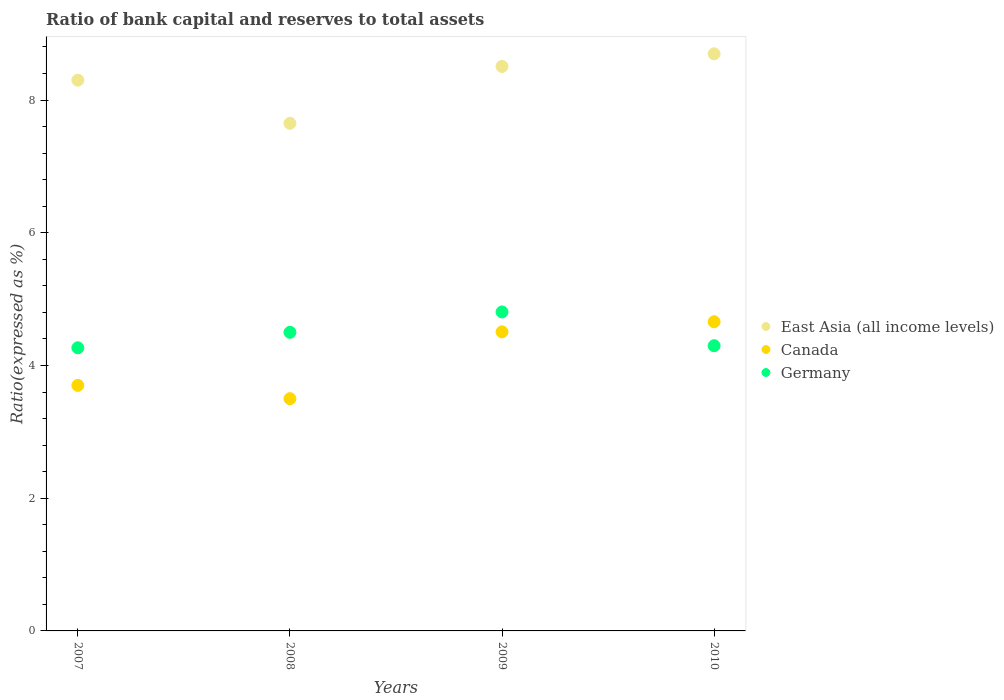How many different coloured dotlines are there?
Give a very brief answer. 3. Is the number of dotlines equal to the number of legend labels?
Provide a succinct answer. Yes. What is the ratio of bank capital and reserves to total assets in East Asia (all income levels) in 2009?
Provide a short and direct response. 8.51. Across all years, what is the maximum ratio of bank capital and reserves to total assets in Canada?
Offer a very short reply. 4.66. Across all years, what is the minimum ratio of bank capital and reserves to total assets in East Asia (all income levels)?
Your response must be concise. 7.65. In which year was the ratio of bank capital and reserves to total assets in East Asia (all income levels) maximum?
Keep it short and to the point. 2010. What is the total ratio of bank capital and reserves to total assets in Germany in the graph?
Provide a short and direct response. 17.87. What is the difference between the ratio of bank capital and reserves to total assets in Germany in 2007 and that in 2008?
Provide a succinct answer. -0.23. What is the difference between the ratio of bank capital and reserves to total assets in East Asia (all income levels) in 2008 and the ratio of bank capital and reserves to total assets in Canada in 2010?
Provide a succinct answer. 2.99. What is the average ratio of bank capital and reserves to total assets in Germany per year?
Make the answer very short. 4.47. In how many years, is the ratio of bank capital and reserves to total assets in East Asia (all income levels) greater than 1.2000000000000002 %?
Give a very brief answer. 4. What is the ratio of the ratio of bank capital and reserves to total assets in East Asia (all income levels) in 2007 to that in 2010?
Provide a succinct answer. 0.95. Is the ratio of bank capital and reserves to total assets in East Asia (all income levels) in 2008 less than that in 2009?
Offer a very short reply. Yes. Is the difference between the ratio of bank capital and reserves to total assets in Germany in 2009 and 2010 greater than the difference between the ratio of bank capital and reserves to total assets in Canada in 2009 and 2010?
Keep it short and to the point. Yes. What is the difference between the highest and the second highest ratio of bank capital and reserves to total assets in East Asia (all income levels)?
Your answer should be compact. 0.19. What is the difference between the highest and the lowest ratio of bank capital and reserves to total assets in East Asia (all income levels)?
Offer a terse response. 1.05. Is it the case that in every year, the sum of the ratio of bank capital and reserves to total assets in Germany and ratio of bank capital and reserves to total assets in East Asia (all income levels)  is greater than the ratio of bank capital and reserves to total assets in Canada?
Give a very brief answer. Yes. How many dotlines are there?
Keep it short and to the point. 3. How many years are there in the graph?
Provide a succinct answer. 4. What is the difference between two consecutive major ticks on the Y-axis?
Keep it short and to the point. 2. Are the values on the major ticks of Y-axis written in scientific E-notation?
Give a very brief answer. No. Where does the legend appear in the graph?
Provide a short and direct response. Center right. How many legend labels are there?
Your answer should be compact. 3. How are the legend labels stacked?
Ensure brevity in your answer.  Vertical. What is the title of the graph?
Offer a very short reply. Ratio of bank capital and reserves to total assets. What is the label or title of the X-axis?
Ensure brevity in your answer.  Years. What is the label or title of the Y-axis?
Your response must be concise. Ratio(expressed as %). What is the Ratio(expressed as %) of Germany in 2007?
Offer a terse response. 4.27. What is the Ratio(expressed as %) in East Asia (all income levels) in 2008?
Offer a very short reply. 7.65. What is the Ratio(expressed as %) of Canada in 2008?
Offer a terse response. 3.5. What is the Ratio(expressed as %) of Germany in 2008?
Make the answer very short. 4.5. What is the Ratio(expressed as %) in East Asia (all income levels) in 2009?
Your answer should be very brief. 8.51. What is the Ratio(expressed as %) in Canada in 2009?
Your answer should be compact. 4.51. What is the Ratio(expressed as %) of Germany in 2009?
Your answer should be very brief. 4.81. What is the Ratio(expressed as %) of East Asia (all income levels) in 2010?
Provide a short and direct response. 8.7. What is the Ratio(expressed as %) in Canada in 2010?
Your answer should be compact. 4.66. What is the Ratio(expressed as %) in Germany in 2010?
Offer a terse response. 4.3. Across all years, what is the maximum Ratio(expressed as %) of East Asia (all income levels)?
Provide a succinct answer. 8.7. Across all years, what is the maximum Ratio(expressed as %) in Canada?
Make the answer very short. 4.66. Across all years, what is the maximum Ratio(expressed as %) of Germany?
Offer a very short reply. 4.81. Across all years, what is the minimum Ratio(expressed as %) of East Asia (all income levels)?
Keep it short and to the point. 7.65. Across all years, what is the minimum Ratio(expressed as %) of Germany?
Provide a succinct answer. 4.27. What is the total Ratio(expressed as %) in East Asia (all income levels) in the graph?
Give a very brief answer. 33.15. What is the total Ratio(expressed as %) in Canada in the graph?
Make the answer very short. 16.37. What is the total Ratio(expressed as %) in Germany in the graph?
Provide a succinct answer. 17.87. What is the difference between the Ratio(expressed as %) of East Asia (all income levels) in 2007 and that in 2008?
Ensure brevity in your answer.  0.65. What is the difference between the Ratio(expressed as %) in Germany in 2007 and that in 2008?
Give a very brief answer. -0.23. What is the difference between the Ratio(expressed as %) in East Asia (all income levels) in 2007 and that in 2009?
Offer a very short reply. -0.21. What is the difference between the Ratio(expressed as %) of Canada in 2007 and that in 2009?
Make the answer very short. -0.81. What is the difference between the Ratio(expressed as %) of Germany in 2007 and that in 2009?
Give a very brief answer. -0.54. What is the difference between the Ratio(expressed as %) in East Asia (all income levels) in 2007 and that in 2010?
Ensure brevity in your answer.  -0.4. What is the difference between the Ratio(expressed as %) in Canada in 2007 and that in 2010?
Your answer should be compact. -0.96. What is the difference between the Ratio(expressed as %) of Germany in 2007 and that in 2010?
Give a very brief answer. -0.03. What is the difference between the Ratio(expressed as %) of East Asia (all income levels) in 2008 and that in 2009?
Provide a succinct answer. -0.86. What is the difference between the Ratio(expressed as %) of Canada in 2008 and that in 2009?
Offer a terse response. -1.01. What is the difference between the Ratio(expressed as %) of Germany in 2008 and that in 2009?
Keep it short and to the point. -0.31. What is the difference between the Ratio(expressed as %) of East Asia (all income levels) in 2008 and that in 2010?
Ensure brevity in your answer.  -1.05. What is the difference between the Ratio(expressed as %) in Canada in 2008 and that in 2010?
Keep it short and to the point. -1.16. What is the difference between the Ratio(expressed as %) in Germany in 2008 and that in 2010?
Offer a terse response. 0.2. What is the difference between the Ratio(expressed as %) in East Asia (all income levels) in 2009 and that in 2010?
Provide a succinct answer. -0.19. What is the difference between the Ratio(expressed as %) of Canada in 2009 and that in 2010?
Provide a short and direct response. -0.15. What is the difference between the Ratio(expressed as %) in Germany in 2009 and that in 2010?
Your response must be concise. 0.51. What is the difference between the Ratio(expressed as %) of East Asia (all income levels) in 2007 and the Ratio(expressed as %) of Germany in 2008?
Make the answer very short. 3.8. What is the difference between the Ratio(expressed as %) of East Asia (all income levels) in 2007 and the Ratio(expressed as %) of Canada in 2009?
Keep it short and to the point. 3.79. What is the difference between the Ratio(expressed as %) in East Asia (all income levels) in 2007 and the Ratio(expressed as %) in Germany in 2009?
Make the answer very short. 3.49. What is the difference between the Ratio(expressed as %) of Canada in 2007 and the Ratio(expressed as %) of Germany in 2009?
Ensure brevity in your answer.  -1.11. What is the difference between the Ratio(expressed as %) in East Asia (all income levels) in 2007 and the Ratio(expressed as %) in Canada in 2010?
Keep it short and to the point. 3.64. What is the difference between the Ratio(expressed as %) in East Asia (all income levels) in 2007 and the Ratio(expressed as %) in Germany in 2010?
Provide a succinct answer. 4. What is the difference between the Ratio(expressed as %) of Canada in 2007 and the Ratio(expressed as %) of Germany in 2010?
Make the answer very short. -0.6. What is the difference between the Ratio(expressed as %) of East Asia (all income levels) in 2008 and the Ratio(expressed as %) of Canada in 2009?
Give a very brief answer. 3.14. What is the difference between the Ratio(expressed as %) in East Asia (all income levels) in 2008 and the Ratio(expressed as %) in Germany in 2009?
Your answer should be compact. 2.84. What is the difference between the Ratio(expressed as %) in Canada in 2008 and the Ratio(expressed as %) in Germany in 2009?
Your answer should be compact. -1.31. What is the difference between the Ratio(expressed as %) in East Asia (all income levels) in 2008 and the Ratio(expressed as %) in Canada in 2010?
Provide a succinct answer. 2.99. What is the difference between the Ratio(expressed as %) in East Asia (all income levels) in 2008 and the Ratio(expressed as %) in Germany in 2010?
Ensure brevity in your answer.  3.35. What is the difference between the Ratio(expressed as %) in Canada in 2008 and the Ratio(expressed as %) in Germany in 2010?
Provide a succinct answer. -0.8. What is the difference between the Ratio(expressed as %) of East Asia (all income levels) in 2009 and the Ratio(expressed as %) of Canada in 2010?
Ensure brevity in your answer.  3.85. What is the difference between the Ratio(expressed as %) of East Asia (all income levels) in 2009 and the Ratio(expressed as %) of Germany in 2010?
Provide a succinct answer. 4.21. What is the difference between the Ratio(expressed as %) of Canada in 2009 and the Ratio(expressed as %) of Germany in 2010?
Provide a short and direct response. 0.21. What is the average Ratio(expressed as %) of East Asia (all income levels) per year?
Keep it short and to the point. 8.29. What is the average Ratio(expressed as %) of Canada per year?
Your response must be concise. 4.09. What is the average Ratio(expressed as %) of Germany per year?
Ensure brevity in your answer.  4.47. In the year 2007, what is the difference between the Ratio(expressed as %) in East Asia (all income levels) and Ratio(expressed as %) in Germany?
Your answer should be compact. 4.03. In the year 2007, what is the difference between the Ratio(expressed as %) of Canada and Ratio(expressed as %) of Germany?
Your answer should be very brief. -0.57. In the year 2008, what is the difference between the Ratio(expressed as %) of East Asia (all income levels) and Ratio(expressed as %) of Canada?
Ensure brevity in your answer.  4.15. In the year 2008, what is the difference between the Ratio(expressed as %) in East Asia (all income levels) and Ratio(expressed as %) in Germany?
Your answer should be very brief. 3.15. In the year 2009, what is the difference between the Ratio(expressed as %) in East Asia (all income levels) and Ratio(expressed as %) in Canada?
Ensure brevity in your answer.  4. In the year 2009, what is the difference between the Ratio(expressed as %) of East Asia (all income levels) and Ratio(expressed as %) of Germany?
Offer a very short reply. 3.7. In the year 2009, what is the difference between the Ratio(expressed as %) of Canada and Ratio(expressed as %) of Germany?
Give a very brief answer. -0.3. In the year 2010, what is the difference between the Ratio(expressed as %) in East Asia (all income levels) and Ratio(expressed as %) in Canada?
Your answer should be compact. 4.04. In the year 2010, what is the difference between the Ratio(expressed as %) of East Asia (all income levels) and Ratio(expressed as %) of Germany?
Offer a terse response. 4.4. In the year 2010, what is the difference between the Ratio(expressed as %) of Canada and Ratio(expressed as %) of Germany?
Keep it short and to the point. 0.36. What is the ratio of the Ratio(expressed as %) of East Asia (all income levels) in 2007 to that in 2008?
Make the answer very short. 1.08. What is the ratio of the Ratio(expressed as %) of Canada in 2007 to that in 2008?
Your response must be concise. 1.06. What is the ratio of the Ratio(expressed as %) in Germany in 2007 to that in 2008?
Your answer should be very brief. 0.95. What is the ratio of the Ratio(expressed as %) of East Asia (all income levels) in 2007 to that in 2009?
Your answer should be compact. 0.98. What is the ratio of the Ratio(expressed as %) in Canada in 2007 to that in 2009?
Provide a succinct answer. 0.82. What is the ratio of the Ratio(expressed as %) of Germany in 2007 to that in 2009?
Keep it short and to the point. 0.89. What is the ratio of the Ratio(expressed as %) in East Asia (all income levels) in 2007 to that in 2010?
Offer a terse response. 0.95. What is the ratio of the Ratio(expressed as %) of Canada in 2007 to that in 2010?
Offer a very short reply. 0.79. What is the ratio of the Ratio(expressed as %) of Germany in 2007 to that in 2010?
Make the answer very short. 0.99. What is the ratio of the Ratio(expressed as %) of East Asia (all income levels) in 2008 to that in 2009?
Ensure brevity in your answer.  0.9. What is the ratio of the Ratio(expressed as %) in Canada in 2008 to that in 2009?
Offer a terse response. 0.78. What is the ratio of the Ratio(expressed as %) in Germany in 2008 to that in 2009?
Keep it short and to the point. 0.94. What is the ratio of the Ratio(expressed as %) of East Asia (all income levels) in 2008 to that in 2010?
Keep it short and to the point. 0.88. What is the ratio of the Ratio(expressed as %) in Canada in 2008 to that in 2010?
Your response must be concise. 0.75. What is the ratio of the Ratio(expressed as %) of Germany in 2008 to that in 2010?
Offer a very short reply. 1.05. What is the ratio of the Ratio(expressed as %) of East Asia (all income levels) in 2009 to that in 2010?
Provide a short and direct response. 0.98. What is the ratio of the Ratio(expressed as %) in Canada in 2009 to that in 2010?
Offer a terse response. 0.97. What is the ratio of the Ratio(expressed as %) in Germany in 2009 to that in 2010?
Your response must be concise. 1.12. What is the difference between the highest and the second highest Ratio(expressed as %) in East Asia (all income levels)?
Make the answer very short. 0.19. What is the difference between the highest and the second highest Ratio(expressed as %) of Canada?
Provide a succinct answer. 0.15. What is the difference between the highest and the second highest Ratio(expressed as %) in Germany?
Make the answer very short. 0.31. What is the difference between the highest and the lowest Ratio(expressed as %) of East Asia (all income levels)?
Provide a succinct answer. 1.05. What is the difference between the highest and the lowest Ratio(expressed as %) in Canada?
Offer a terse response. 1.16. What is the difference between the highest and the lowest Ratio(expressed as %) of Germany?
Your response must be concise. 0.54. 